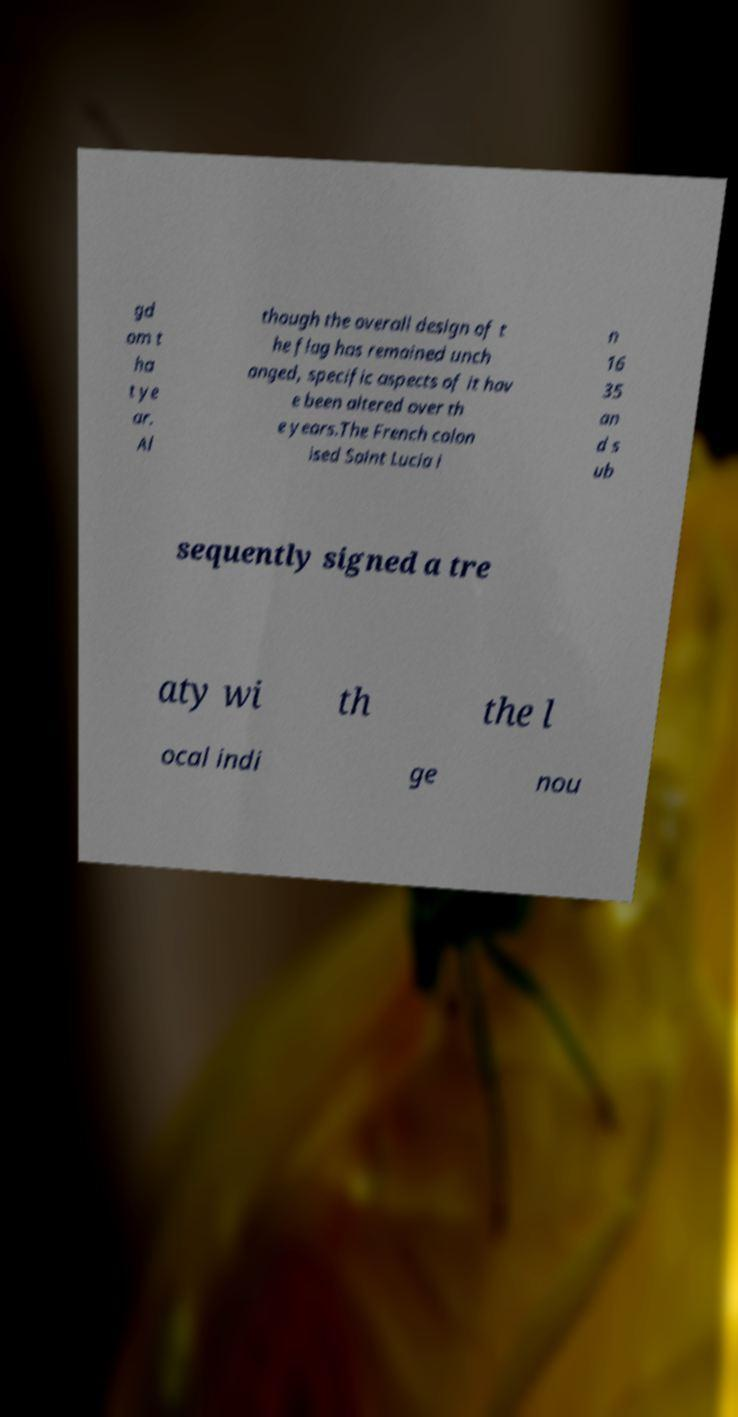For documentation purposes, I need the text within this image transcribed. Could you provide that? gd om t ha t ye ar. Al though the overall design of t he flag has remained unch anged, specific aspects of it hav e been altered over th e years.The French colon ised Saint Lucia i n 16 35 an d s ub sequently signed a tre aty wi th the l ocal indi ge nou 